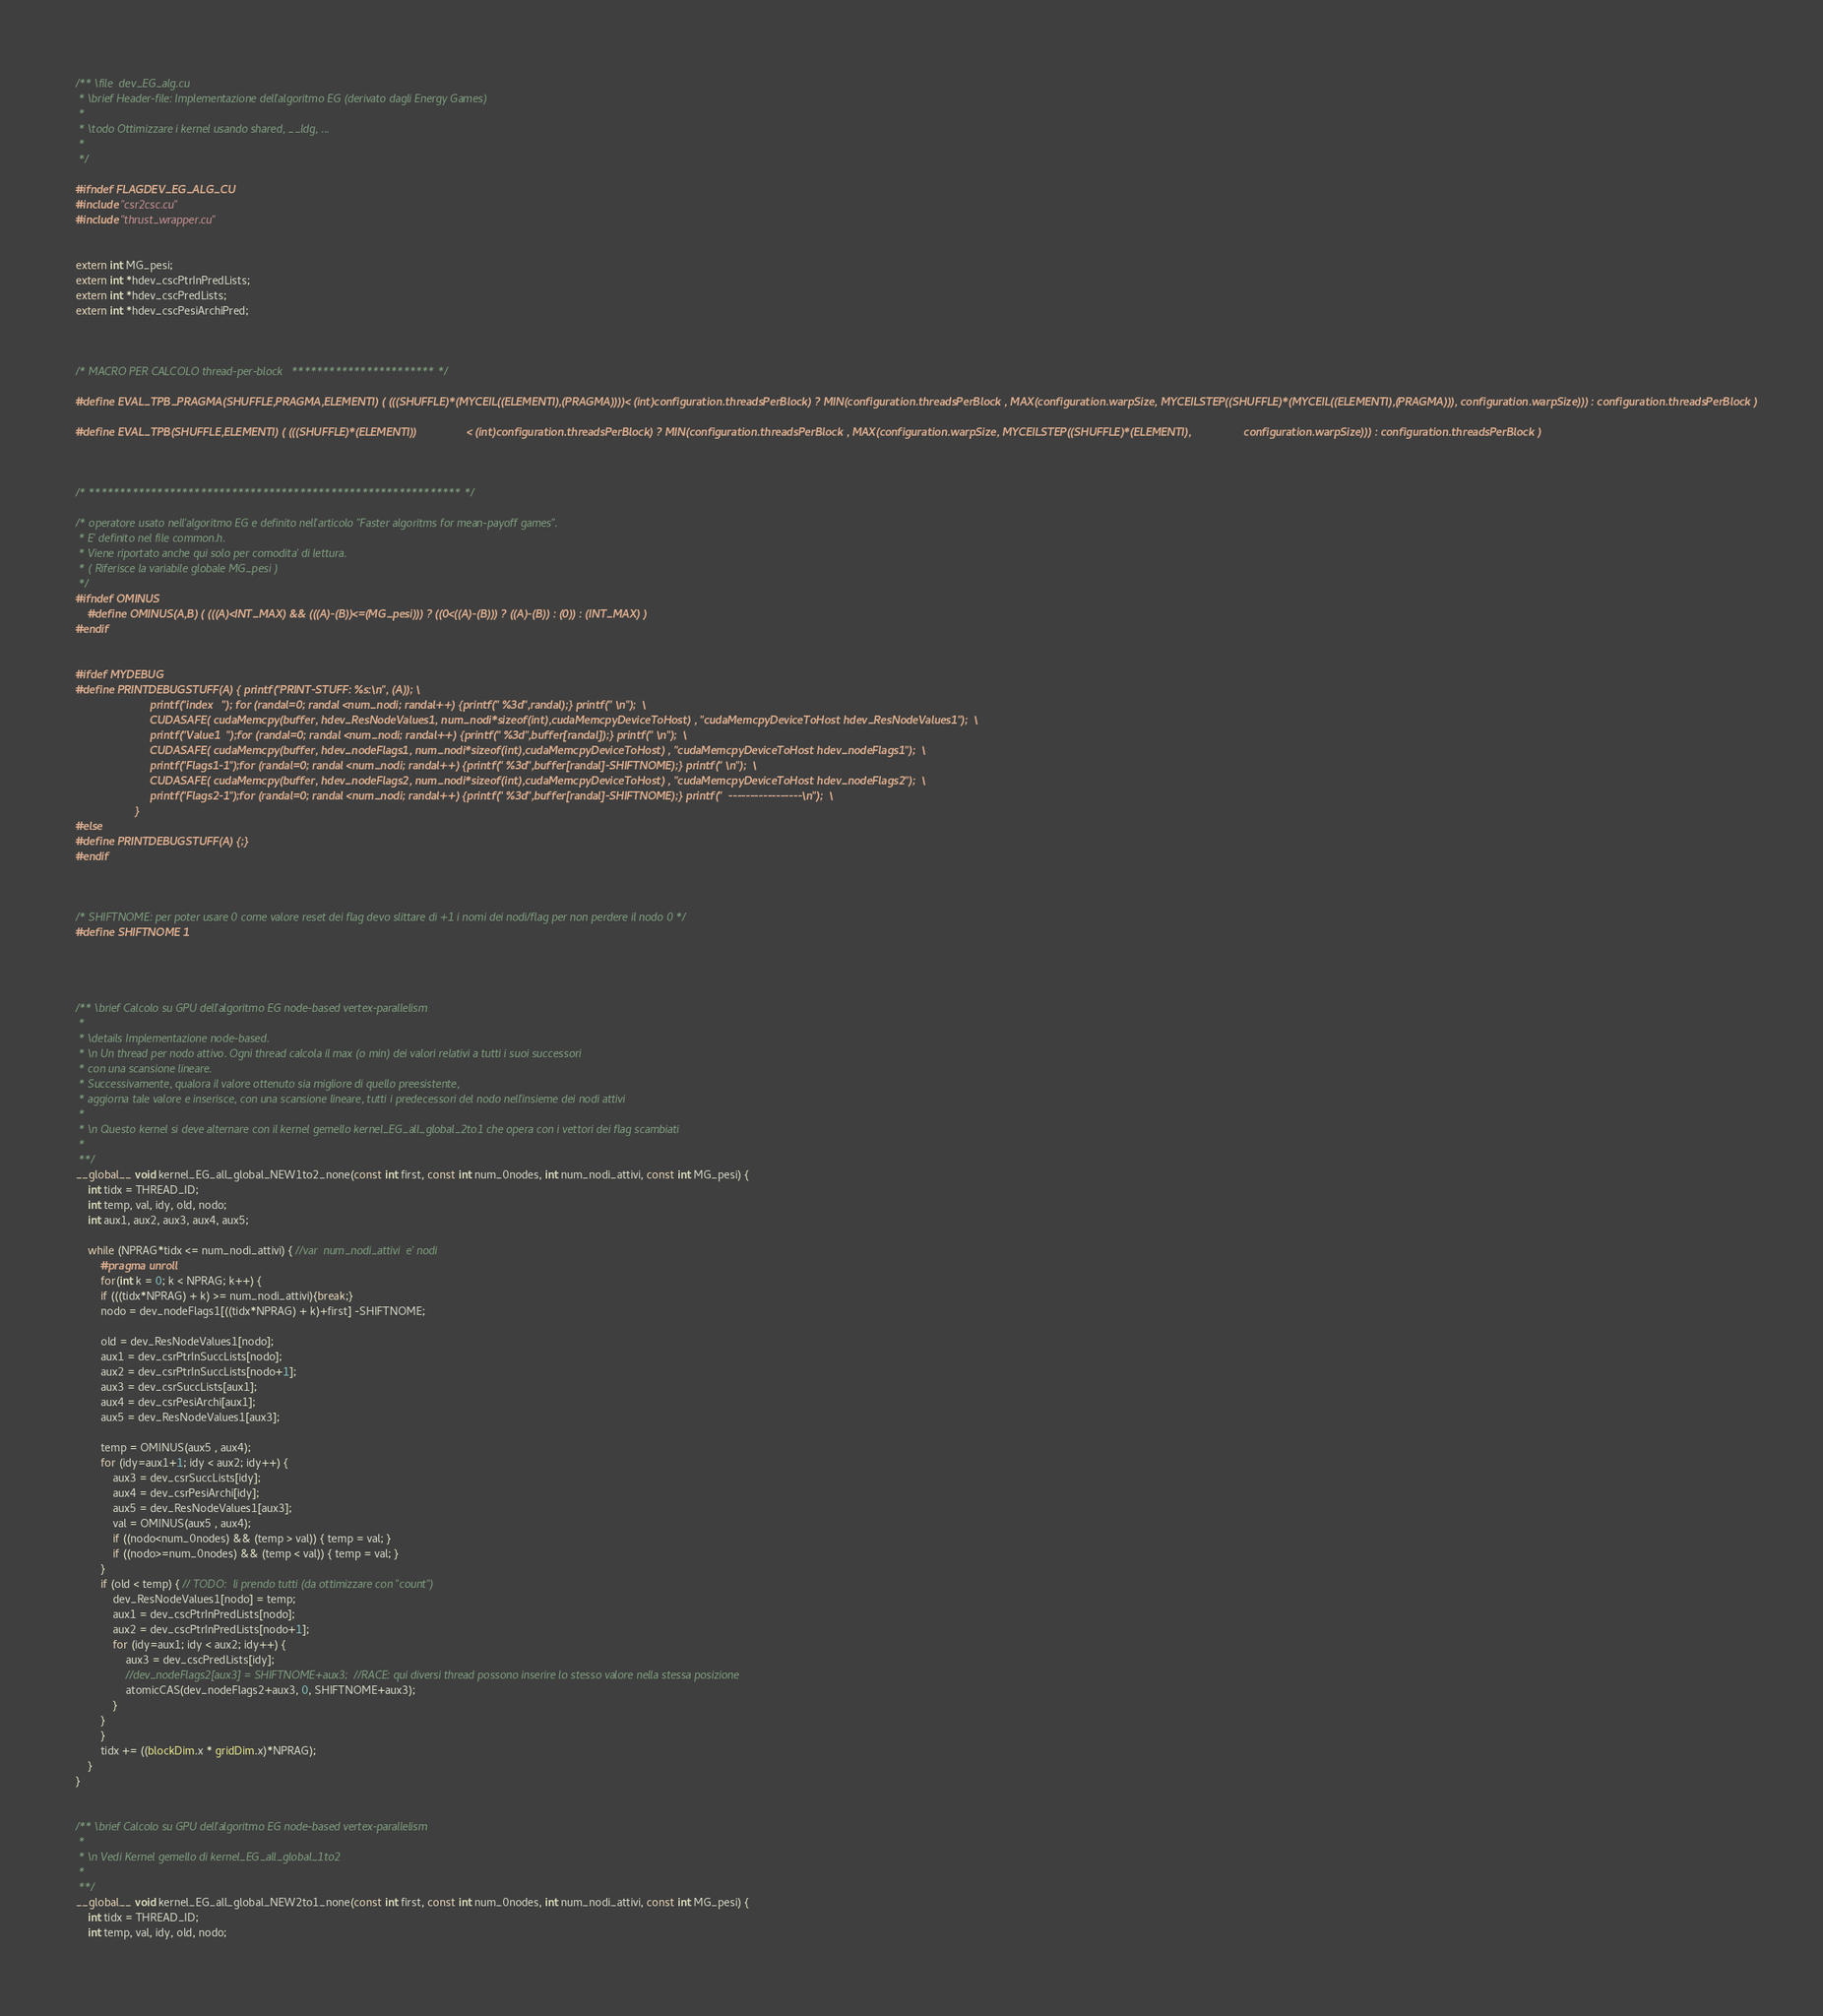Convert code to text. <code><loc_0><loc_0><loc_500><loc_500><_Cuda_>/** \file  dev_EG_alg.cu
 * \brief Header-file: Implementazione dell'algoritmo EG (derivato dagli Energy Games) 
 *
 * \todo Ottimizzare i kernel usando shared, __ldg, ...
 *
 */

#ifndef FLAGDEV_EG_ALG_CU
#include "csr2csc.cu"
#include "thrust_wrapper.cu"


extern int MG_pesi;
extern int *hdev_cscPtrInPredLists;
extern int *hdev_cscPredLists;
extern int *hdev_cscPesiArchiPred;



/* MACRO PER CALCOLO thread-per-block   *********************** */

#define EVAL_TPB_PRAGMA(SHUFFLE,PRAGMA,ELEMENTI) ( (((SHUFFLE)*(MYCEIL((ELEMENTI),(PRAGMA))))< (int)configuration.threadsPerBlock) ? MIN(configuration.threadsPerBlock , MAX(configuration.warpSize, MYCEILSTEP((SHUFFLE)*(MYCEIL((ELEMENTI),(PRAGMA))), configuration.warpSize))) : configuration.threadsPerBlock )

#define EVAL_TPB(SHUFFLE,ELEMENTI) ( (((SHUFFLE)*(ELEMENTI))                < (int)configuration.threadsPerBlock) ? MIN(configuration.threadsPerBlock , MAX(configuration.warpSize, MYCEILSTEP((SHUFFLE)*(ELEMENTI),                 configuration.warpSize))) : configuration.threadsPerBlock )



/* ************************************************************ */

/* operatore usato nell'algoritmo EG e definito nell'articolo "Faster algoritms for mean-payoff games".
 * E' definito nel file common.h.
 * Viene riportato anche qui solo per comodita' di lettura.
 * ( Riferisce la variabile globale MG_pesi )
 */
#ifndef OMINUS
	#define OMINUS(A,B) ( (((A)<INT_MAX) && (((A)-(B))<=(MG_pesi))) ? ((0<((A)-(B))) ? ((A)-(B)) : (0)) : (INT_MAX) )
#endif


#ifdef MYDEBUG
#define PRINTDEBUGSTUFF(A) { printf("PRINT-STUFF: %s:\n", (A)); \
                        printf("index   "); for (randal=0; randal <num_nodi; randal++) {printf(" %3d",randal);} printf(" \n");  \
                        CUDASAFE( cudaMemcpy(buffer, hdev_ResNodeValues1, num_nodi*sizeof(int),cudaMemcpyDeviceToHost) , "cudaMemcpyDeviceToHost hdev_ResNodeValues1");  \
                        printf("Value1  ");for (randal=0; randal <num_nodi; randal++) {printf(" %3d",buffer[randal]);} printf(" \n");  \
                        CUDASAFE( cudaMemcpy(buffer, hdev_nodeFlags1, num_nodi*sizeof(int),cudaMemcpyDeviceToHost) , "cudaMemcpyDeviceToHost hdev_nodeFlags1");  \
                        printf("Flags1-1");for (randal=0; randal <num_nodi; randal++) {printf(" %3d",buffer[randal]-SHIFTNOME);} printf(" \n");  \
                        CUDASAFE( cudaMemcpy(buffer, hdev_nodeFlags2, num_nodi*sizeof(int),cudaMemcpyDeviceToHost) , "cudaMemcpyDeviceToHost hdev_nodeFlags2");  \
                        printf("Flags2-1");for (randal=0; randal <num_nodi; randal++) {printf(" %3d",buffer[randal]-SHIFTNOME);} printf("  -----------------\n");  \
                   }
#else
#define PRINTDEBUGSTUFF(A) {;}
#endif



/* SHIFTNOME: per poter usare 0 come valore reset dei flag devo slittare di +1 i nomi dei nodi/flag per non perdere il nodo 0 */
#define SHIFTNOME 1




/** \brief Calcolo su GPU dell'algoritmo EG node-based vertex-parallelism
 *
 * \details Implementazione node-based.
 * \n Un thread per nodo attivo. Ogni thread calcola il max (o min) dei valori relativi a tutti i suoi successori
 * con una scansione lineare.
 * Successivamente, qualora il valore ottenuto sia migliore di quello preesistente,
 * aggiorna tale valore e inserisce, con una scansione lineare, tutti i predecessori del nodo nell'insieme dei nodi attivi
 *
 * \n Questo kernel si deve alternare con il kernel gemello kernel_EG_all_global_2to1 che opera con i vettori dei flag scambiati
 * 
 **/
__global__ void kernel_EG_all_global_NEW1to2_none(const int first, const int num_0nodes, int num_nodi_attivi, const int MG_pesi) {
	int tidx = THREAD_ID;
	int temp, val, idy, old, nodo;
	int aux1, aux2, aux3, aux4, aux5;
	
	while (NPRAG*tidx <= num_nodi_attivi) { //var  num_nodi_attivi  e' nodi
	    #pragma unroll
	    for(int k = 0; k < NPRAG; k++) {
		if (((tidx*NPRAG) + k) >= num_nodi_attivi){break;}
		nodo = dev_nodeFlags1[((tidx*NPRAG) + k)+first] -SHIFTNOME;

		old = dev_ResNodeValues1[nodo];
		aux1 = dev_csrPtrInSuccLists[nodo];
		aux2 = dev_csrPtrInSuccLists[nodo+1];
		aux3 = dev_csrSuccLists[aux1];
		aux4 = dev_csrPesiArchi[aux1];
		aux5 = dev_ResNodeValues1[aux3];

		temp = OMINUS(aux5 , aux4);
		for (idy=aux1+1; idy < aux2; idy++) {
			aux3 = dev_csrSuccLists[idy];
			aux4 = dev_csrPesiArchi[idy];
			aux5 = dev_ResNodeValues1[aux3];
			val = OMINUS(aux5 , aux4);
			if ((nodo<num_0nodes) && (temp > val)) { temp = val; }
			if ((nodo>=num_0nodes) && (temp < val)) { temp = val; }
		}
		if (old < temp) { // TODO:  li prendo tutti (da ottimizzare con "count")
			dev_ResNodeValues1[nodo] = temp;
			aux1 = dev_cscPtrInPredLists[nodo];
			aux2 = dev_cscPtrInPredLists[nodo+1];
			for (idy=aux1; idy < aux2; idy++) {
				aux3 = dev_cscPredLists[idy];
				//dev_nodeFlags2[aux3] = SHIFTNOME+aux3;  //RACE: qui diversi thread possono inserire lo stesso valore nella stessa posizione
				atomicCAS(dev_nodeFlags2+aux3, 0, SHIFTNOME+aux3); 
			}
		}
	    }
		tidx += ((blockDim.x * gridDim.x)*NPRAG);
	}
}


/** \brief Calcolo su GPU dell'algoritmo EG node-based vertex-parallelism
 *
 * \n Vedi Kernel gemello di kernel_EG_all_global_1to2
 * 
 **/
__global__ void kernel_EG_all_global_NEW2to1_none(const int first, const int num_0nodes, int num_nodi_attivi, const int MG_pesi) {
	int tidx = THREAD_ID;
	int temp, val, idy, old, nodo;</code> 